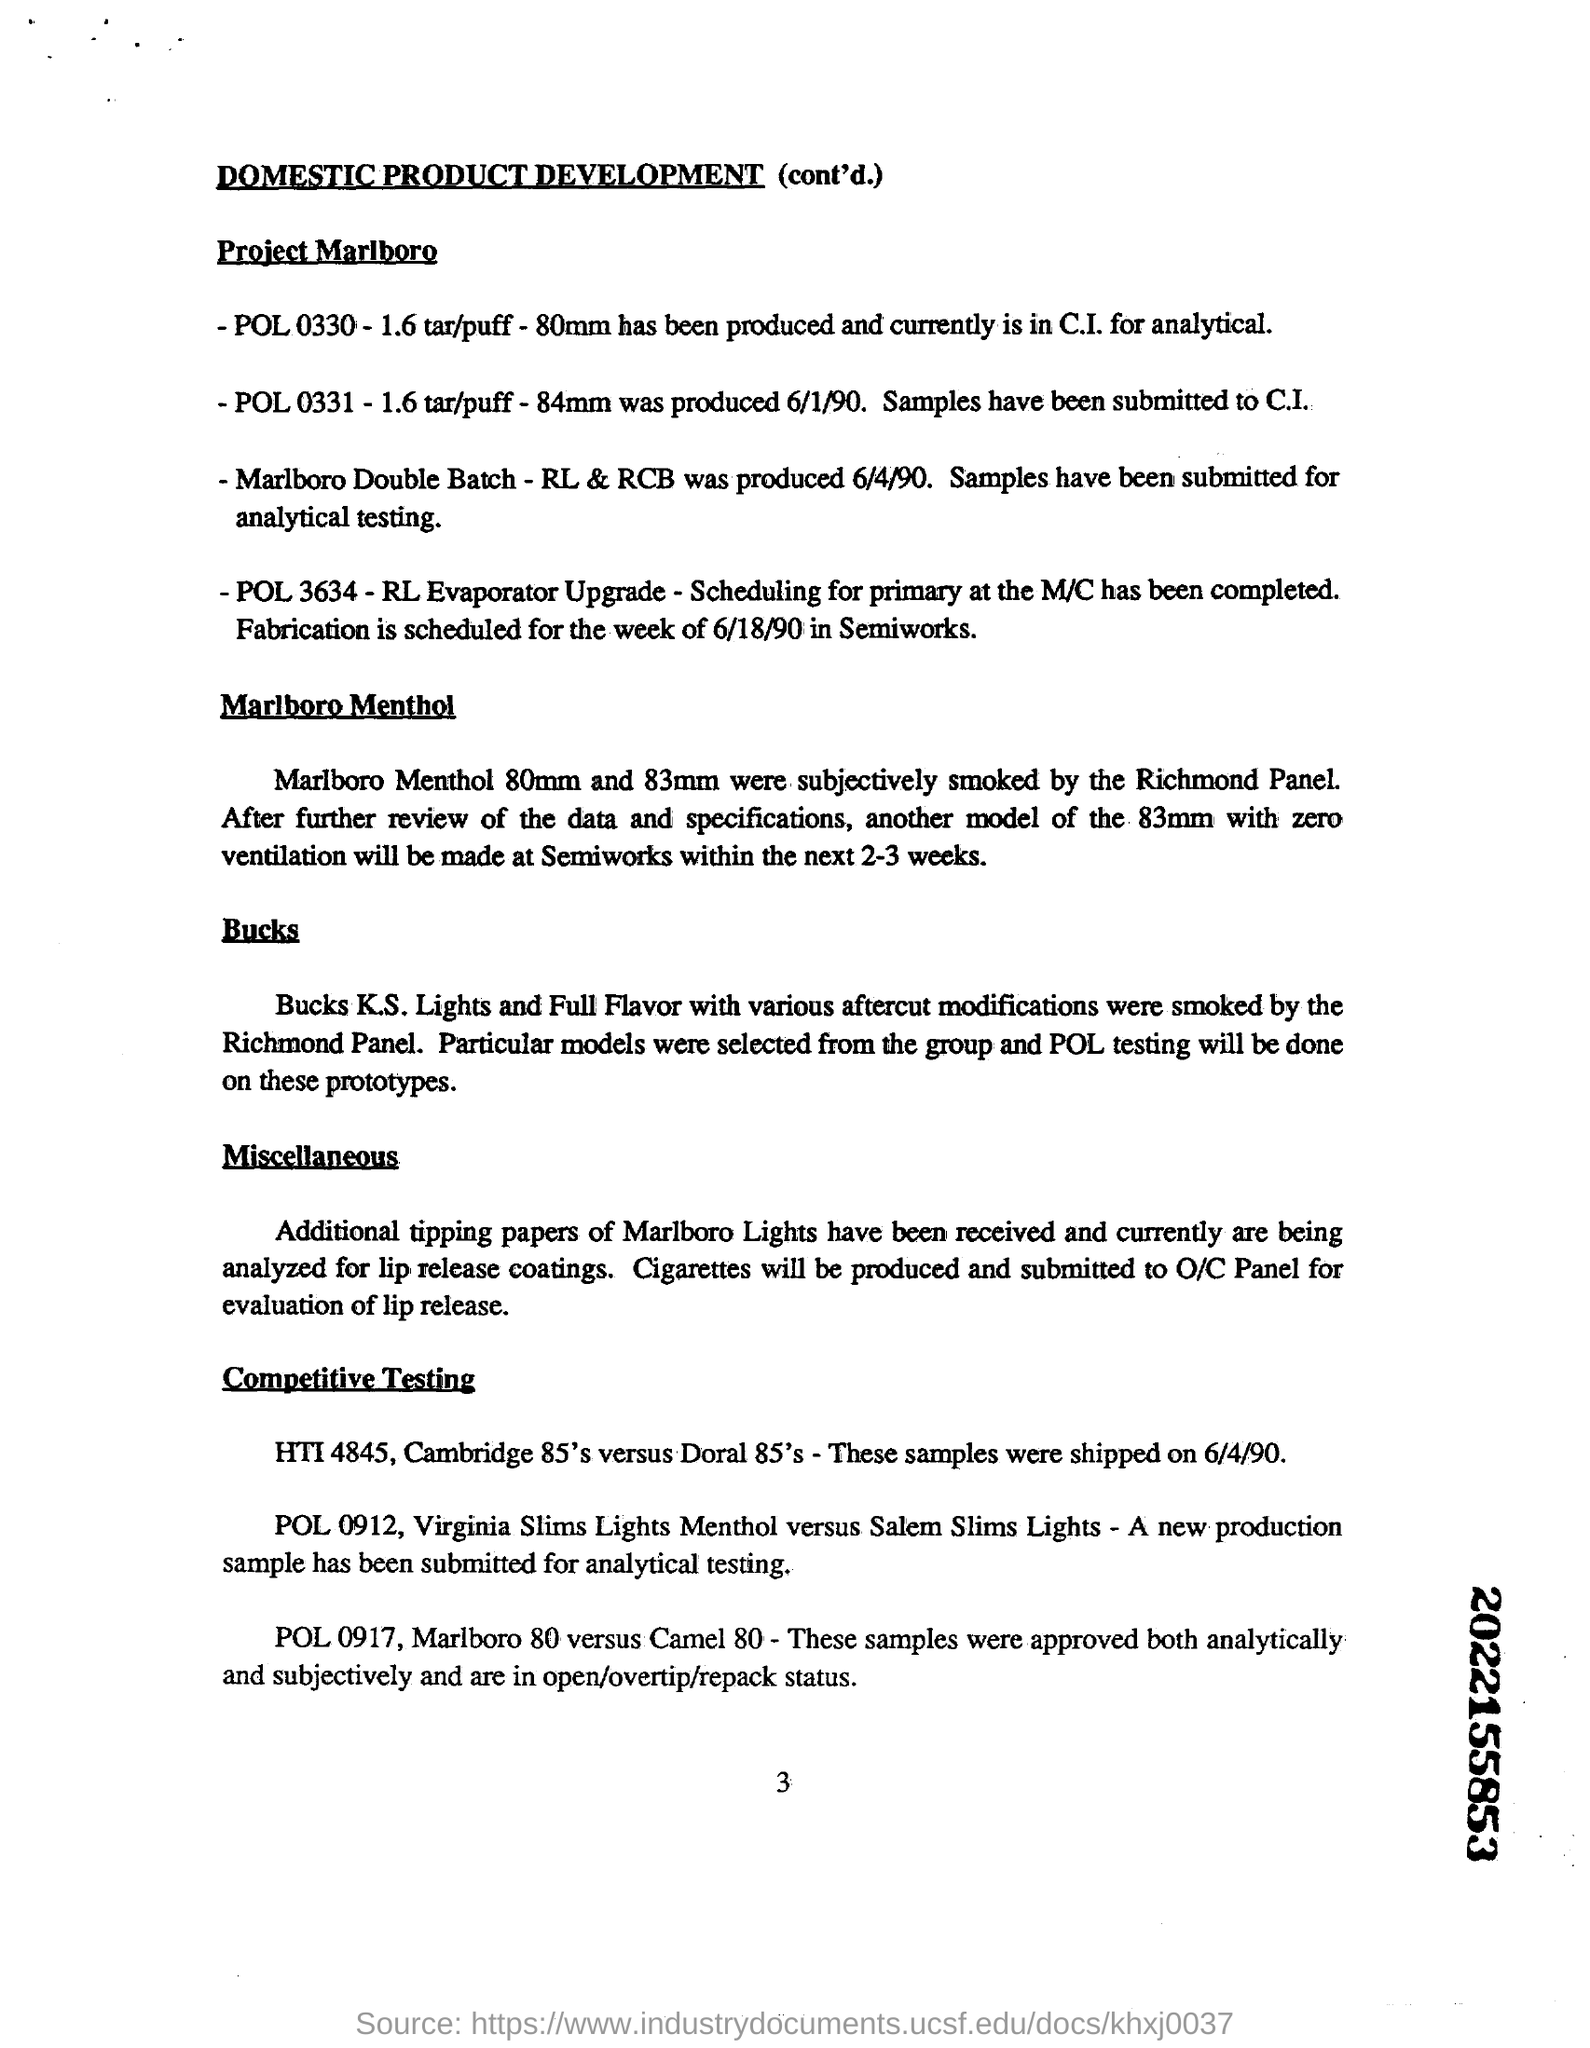Heading of the document
Your response must be concise. Domestic Product Development (cont'd.). What mm marlboro menthol were subjectively smoked by the richmond panel
Your response must be concise. 80mm and 83mm. Cigarettes will be produced and submitted to O/C Panel for what purpose?
Ensure brevity in your answer.  Evaluation of lip release. Another model of the 83mm with zero ventilation will be made at Semiworks within how many weeks
Keep it short and to the point. 2-3 weeks. 